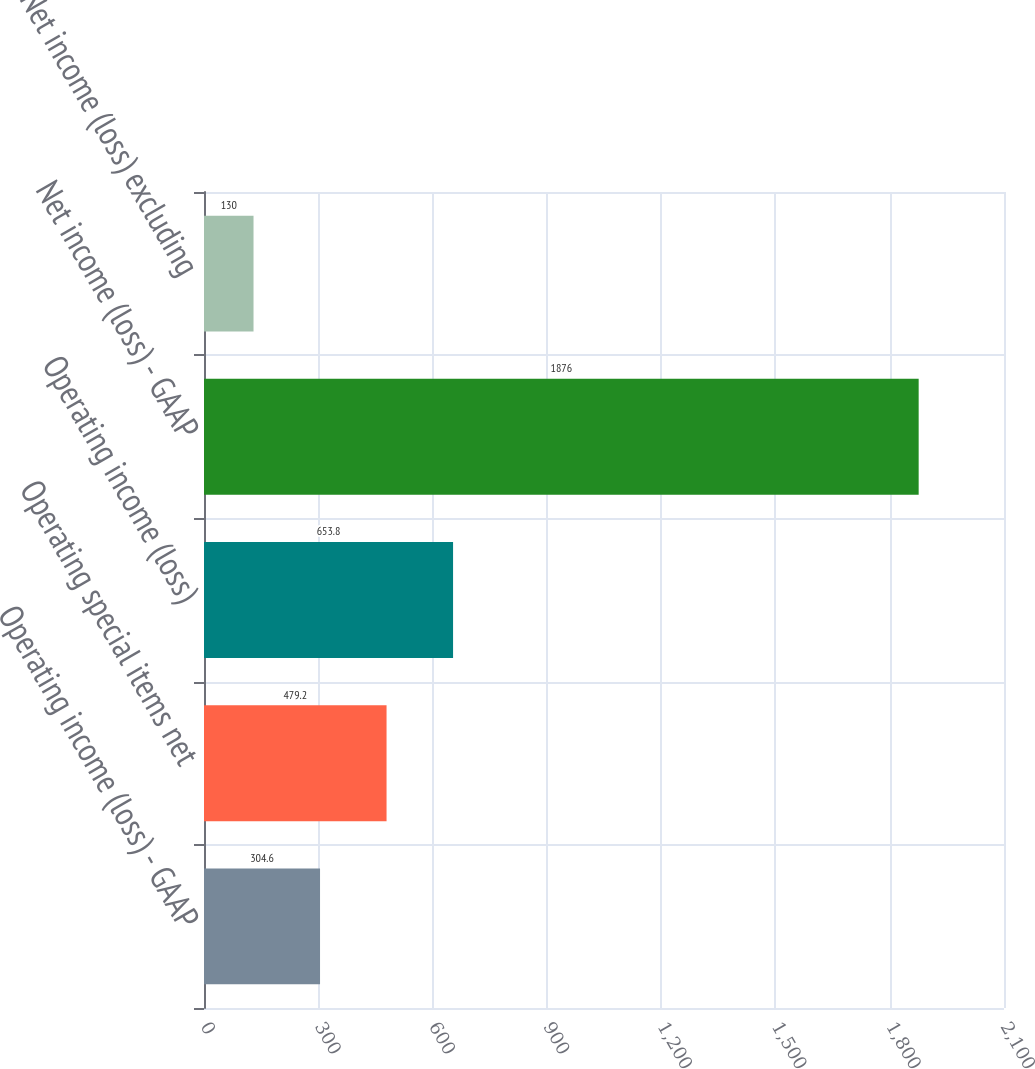<chart> <loc_0><loc_0><loc_500><loc_500><bar_chart><fcel>Operating income (loss) - GAAP<fcel>Operating special items net<fcel>Operating income (loss)<fcel>Net income (loss) - GAAP<fcel>Net income (loss) excluding<nl><fcel>304.6<fcel>479.2<fcel>653.8<fcel>1876<fcel>130<nl></chart> 